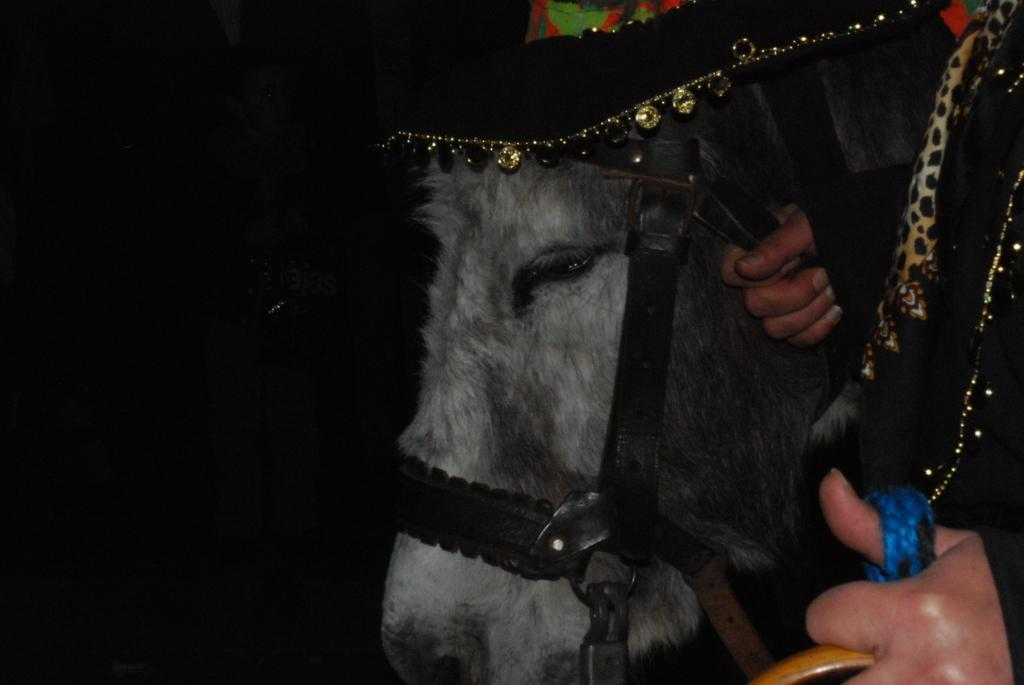What is the main subject of the image? The main subject of the image is a person holding a horse. Can you describe the position of the other person in the image? There is another person standing behind the horse in the image. What type of paste is being used by the person holding the horse in the image? There is no paste present in the image; it features a person holding a horse and another person standing behind the horse. How many fowls are visible in the image? There are no fowls present in the image. 